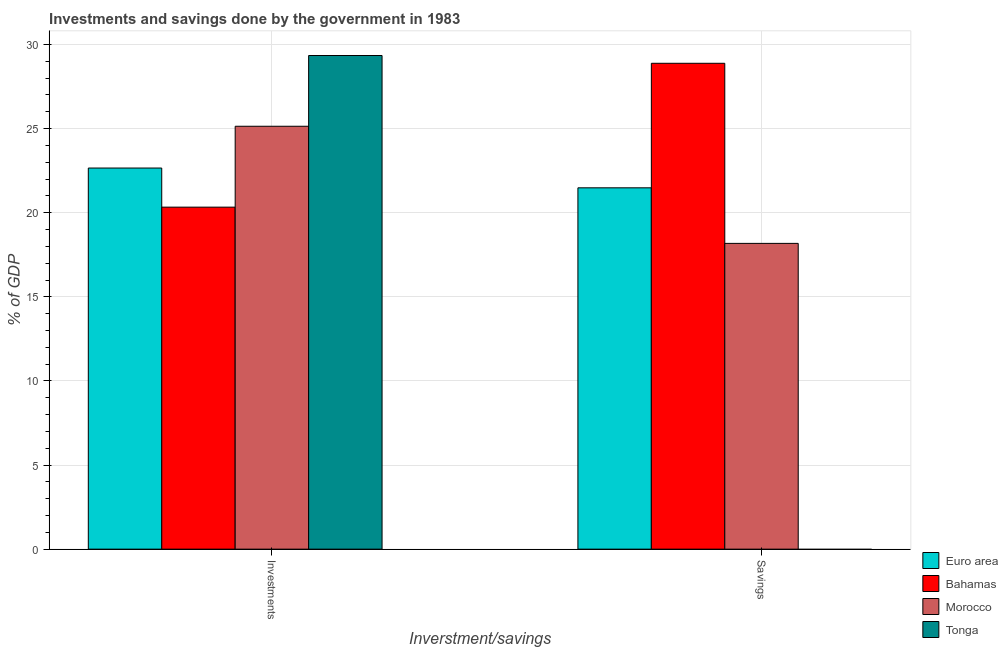How many groups of bars are there?
Your response must be concise. 2. Are the number of bars per tick equal to the number of legend labels?
Your answer should be very brief. No. What is the label of the 2nd group of bars from the left?
Your answer should be very brief. Savings. What is the investments of government in Tonga?
Give a very brief answer. 29.35. Across all countries, what is the maximum savings of government?
Provide a succinct answer. 28.88. Across all countries, what is the minimum investments of government?
Your answer should be compact. 20.33. In which country was the savings of government maximum?
Keep it short and to the point. Bahamas. What is the total investments of government in the graph?
Give a very brief answer. 97.47. What is the difference between the investments of government in Euro area and that in Morocco?
Give a very brief answer. -2.48. What is the difference between the investments of government in Euro area and the savings of government in Tonga?
Give a very brief answer. 22.66. What is the average savings of government per country?
Offer a very short reply. 17.14. What is the difference between the investments of government and savings of government in Euro area?
Offer a very short reply. 1.18. In how many countries, is the savings of government greater than 7 %?
Provide a succinct answer. 3. What is the ratio of the savings of government in Euro area to that in Bahamas?
Keep it short and to the point. 0.74. Is the investments of government in Bahamas less than that in Morocco?
Provide a short and direct response. Yes. How many bars are there?
Give a very brief answer. 7. What is the difference between two consecutive major ticks on the Y-axis?
Ensure brevity in your answer.  5. Does the graph contain grids?
Offer a very short reply. Yes. How are the legend labels stacked?
Your response must be concise. Vertical. What is the title of the graph?
Make the answer very short. Investments and savings done by the government in 1983. What is the label or title of the X-axis?
Ensure brevity in your answer.  Inverstment/savings. What is the label or title of the Y-axis?
Your answer should be compact. % of GDP. What is the % of GDP of Euro area in Investments?
Your answer should be very brief. 22.66. What is the % of GDP of Bahamas in Investments?
Your answer should be very brief. 20.33. What is the % of GDP of Morocco in Investments?
Your response must be concise. 25.14. What is the % of GDP in Tonga in Investments?
Provide a short and direct response. 29.35. What is the % of GDP of Euro area in Savings?
Ensure brevity in your answer.  21.48. What is the % of GDP in Bahamas in Savings?
Offer a terse response. 28.88. What is the % of GDP in Morocco in Savings?
Offer a very short reply. 18.18. Across all Inverstment/savings, what is the maximum % of GDP of Euro area?
Ensure brevity in your answer.  22.66. Across all Inverstment/savings, what is the maximum % of GDP of Bahamas?
Your answer should be very brief. 28.88. Across all Inverstment/savings, what is the maximum % of GDP of Morocco?
Provide a short and direct response. 25.14. Across all Inverstment/savings, what is the maximum % of GDP of Tonga?
Offer a terse response. 29.35. Across all Inverstment/savings, what is the minimum % of GDP of Euro area?
Ensure brevity in your answer.  21.48. Across all Inverstment/savings, what is the minimum % of GDP of Bahamas?
Make the answer very short. 20.33. Across all Inverstment/savings, what is the minimum % of GDP in Morocco?
Give a very brief answer. 18.18. What is the total % of GDP in Euro area in the graph?
Offer a terse response. 44.14. What is the total % of GDP of Bahamas in the graph?
Provide a short and direct response. 49.22. What is the total % of GDP in Morocco in the graph?
Offer a very short reply. 43.32. What is the total % of GDP of Tonga in the graph?
Keep it short and to the point. 29.35. What is the difference between the % of GDP in Euro area in Investments and that in Savings?
Keep it short and to the point. 1.18. What is the difference between the % of GDP in Bahamas in Investments and that in Savings?
Ensure brevity in your answer.  -8.55. What is the difference between the % of GDP in Morocco in Investments and that in Savings?
Offer a terse response. 6.96. What is the difference between the % of GDP in Euro area in Investments and the % of GDP in Bahamas in Savings?
Your response must be concise. -6.23. What is the difference between the % of GDP in Euro area in Investments and the % of GDP in Morocco in Savings?
Provide a short and direct response. 4.48. What is the difference between the % of GDP of Bahamas in Investments and the % of GDP of Morocco in Savings?
Your answer should be compact. 2.15. What is the average % of GDP in Euro area per Inverstment/savings?
Keep it short and to the point. 22.07. What is the average % of GDP of Bahamas per Inverstment/savings?
Offer a very short reply. 24.61. What is the average % of GDP in Morocco per Inverstment/savings?
Offer a very short reply. 21.66. What is the average % of GDP in Tonga per Inverstment/savings?
Keep it short and to the point. 14.67. What is the difference between the % of GDP in Euro area and % of GDP in Bahamas in Investments?
Offer a terse response. 2.33. What is the difference between the % of GDP in Euro area and % of GDP in Morocco in Investments?
Provide a succinct answer. -2.48. What is the difference between the % of GDP of Euro area and % of GDP of Tonga in Investments?
Ensure brevity in your answer.  -6.69. What is the difference between the % of GDP in Bahamas and % of GDP in Morocco in Investments?
Give a very brief answer. -4.81. What is the difference between the % of GDP in Bahamas and % of GDP in Tonga in Investments?
Give a very brief answer. -9.01. What is the difference between the % of GDP of Morocco and % of GDP of Tonga in Investments?
Provide a short and direct response. -4.21. What is the difference between the % of GDP in Euro area and % of GDP in Bahamas in Savings?
Ensure brevity in your answer.  -7.4. What is the difference between the % of GDP in Euro area and % of GDP in Morocco in Savings?
Provide a succinct answer. 3.3. What is the difference between the % of GDP in Bahamas and % of GDP in Morocco in Savings?
Provide a short and direct response. 10.71. What is the ratio of the % of GDP of Euro area in Investments to that in Savings?
Your answer should be very brief. 1.05. What is the ratio of the % of GDP of Bahamas in Investments to that in Savings?
Your answer should be compact. 0.7. What is the ratio of the % of GDP of Morocco in Investments to that in Savings?
Your response must be concise. 1.38. What is the difference between the highest and the second highest % of GDP in Euro area?
Ensure brevity in your answer.  1.18. What is the difference between the highest and the second highest % of GDP in Bahamas?
Make the answer very short. 8.55. What is the difference between the highest and the second highest % of GDP in Morocco?
Offer a very short reply. 6.96. What is the difference between the highest and the lowest % of GDP of Euro area?
Your answer should be compact. 1.18. What is the difference between the highest and the lowest % of GDP in Bahamas?
Your answer should be compact. 8.55. What is the difference between the highest and the lowest % of GDP in Morocco?
Offer a terse response. 6.96. What is the difference between the highest and the lowest % of GDP in Tonga?
Keep it short and to the point. 29.35. 